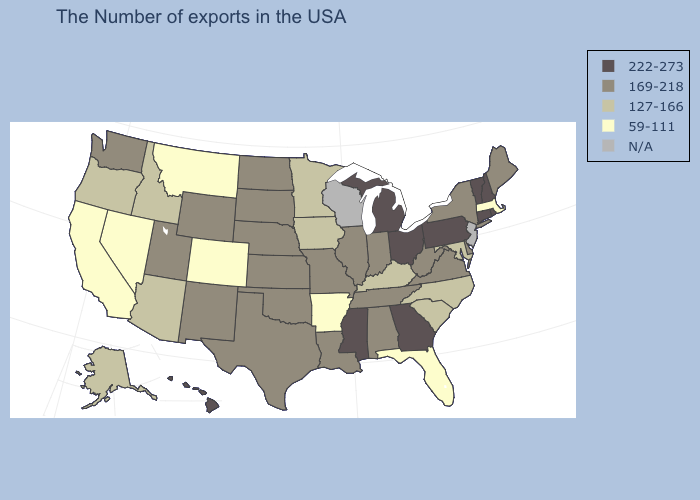What is the value of Wyoming?
Short answer required. 169-218. Does Arizona have the highest value in the West?
Short answer required. No. What is the highest value in the West ?
Keep it brief. 222-273. Name the states that have a value in the range N/A?
Keep it brief. New Jersey, Wisconsin. What is the lowest value in the USA?
Short answer required. 59-111. Name the states that have a value in the range N/A?
Short answer required. New Jersey, Wisconsin. Name the states that have a value in the range N/A?
Keep it brief. New Jersey, Wisconsin. What is the value of Wisconsin?
Write a very short answer. N/A. What is the value of Kentucky?
Give a very brief answer. 127-166. What is the lowest value in the South?
Give a very brief answer. 59-111. What is the highest value in the West ?
Write a very short answer. 222-273. What is the value of Oklahoma?
Short answer required. 169-218. What is the highest value in states that border Texas?
Quick response, please. 169-218. What is the highest value in the USA?
Quick response, please. 222-273. 